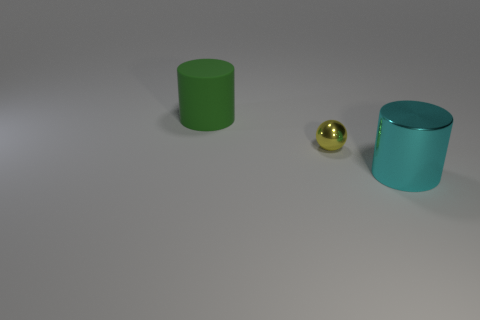There is a green rubber thing; is it the same shape as the metal thing that is on the left side of the large shiny cylinder?
Keep it short and to the point. No. How many objects are both in front of the large matte cylinder and behind the tiny yellow sphere?
Give a very brief answer. 0. Is the tiny yellow thing made of the same material as the large cylinder that is to the left of the cyan cylinder?
Make the answer very short. No. Are there the same number of small objects to the right of the yellow shiny ball and small red metal spheres?
Make the answer very short. Yes. What is the color of the cylinder on the right side of the large matte thing?
Keep it short and to the point. Cyan. What number of other objects are the same color as the tiny metallic object?
Your response must be concise. 0. Is there any other thing that is the same size as the yellow ball?
Make the answer very short. No. There is a metal thing that is on the right side of the yellow ball; is its size the same as the yellow object?
Provide a succinct answer. No. There is a cylinder that is on the right side of the green rubber cylinder; what is its material?
Keep it short and to the point. Metal. Is there any other thing that has the same shape as the tiny yellow shiny object?
Your response must be concise. No. 